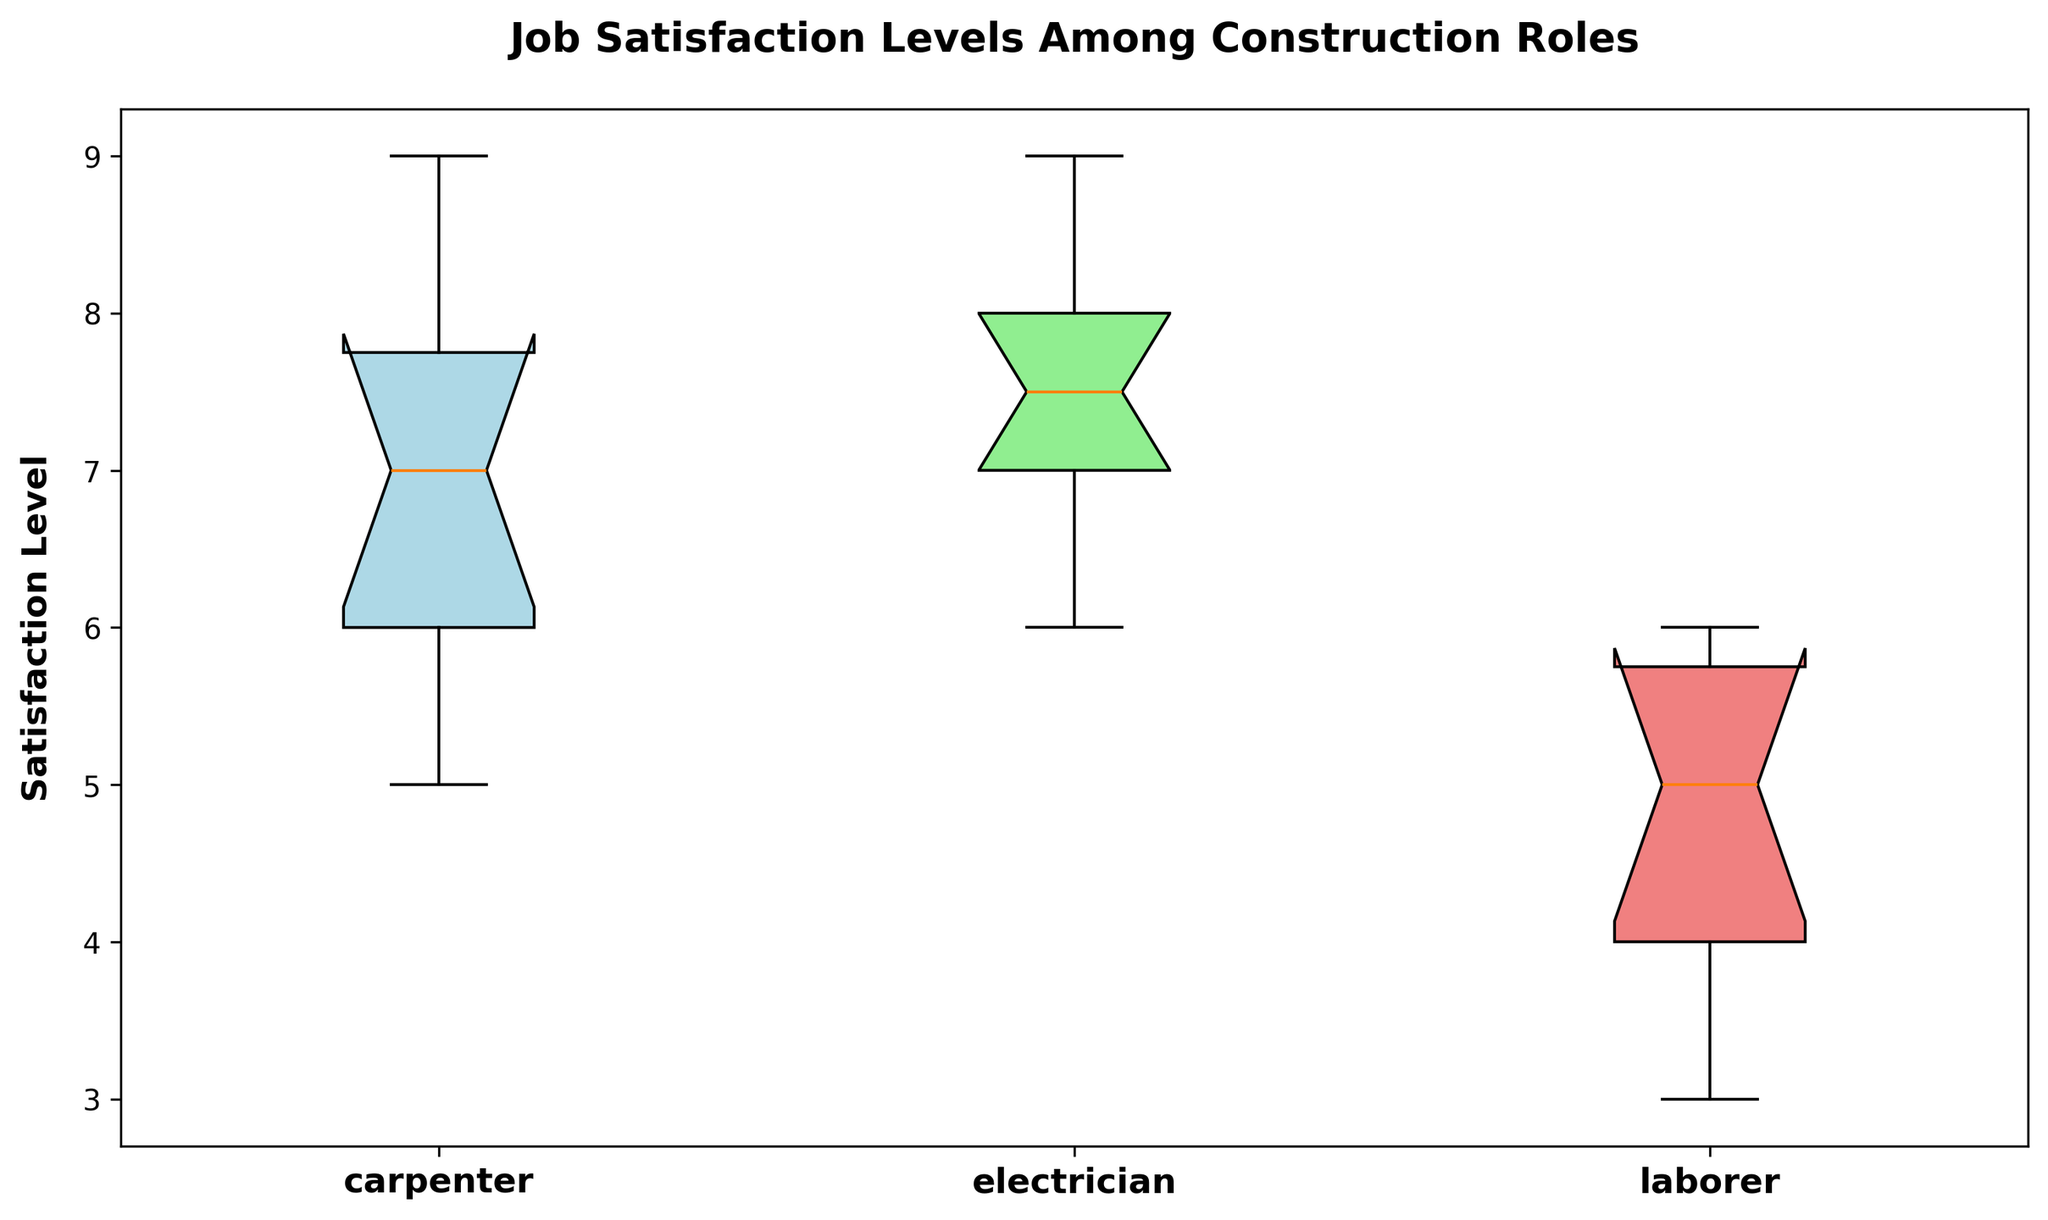what's the median value for electricians? To find the median satisfaction level for electricians, we first arrange the values in ascending order: 6, 7, 7, 7, 7, 8, 8, 8, 9, 9. Since there are 10 values, the median is the average of the 5th and 6th values, (7 + 8)/2 = 7.5
Answer: 7.5 Which role has the highest median job satisfaction level? We compare the median satisfaction levels of all roles. For carpenters, the median is 7. For electricians, it is 7.5. For laborers, it is 5. Hence, electricians have the highest median job satisfaction level.
Answer: electricians What is the interquartile range (IQR) for laborers? The IQR is the difference between the third quartile (Q3) and the first quartile (Q1). For laborers, Q1 is 4 and Q3 is 6. Therefore, IQR = Q3 - Q1 = 6 - 4 = 2
Answer: 2 Which role has the smallest range of job satisfaction levels? To find the range, we look at the difference between the maximum and minimum satisfaction levels. Carpenters range: 9 - 5 = 4, Electricians range: 9 - 6 = 3, Laborers range: 6 - 3 = 3. Electricians and laborers both have the smallest range of 3.
Answer: electricians and laborers What is the difference in the median satisfaction levels between carpenters and laborers? The median satisfaction level for carpenters is 7, and for laborers, it is 5. The difference is 7 - 5 = 2
Answer: 2 Which role has the most variation in job satisfaction levels based on the box plot? Variation in job satisfaction levels can be assessed by looking at the spread between the whiskers and the IQR width. Carpenters have a range of 9 - 5 = 4, Electricians have a range of 9 - 6 = 3, Laborers have a range of 6 - 3 = 3. The IQR is widest for carpenters. Thus, carpenters have the most variation.
Answer: carpenters Which color represents the satisfaction levels of electricians in the box plot? In the box plot, the color correspondent is described: 'lightblue' for carpenters, 'lightgreen' for electricians, and 'lightcoral' for laborers. Thus, electricians are represented by light green.
Answer: light green What is the minimum job satisfaction level for carpenters? The minimum value is the lowest point of the whisker for carpenters. From the provided data, the minimum job satisfaction level for carpenters is 5.
Answer: 5 